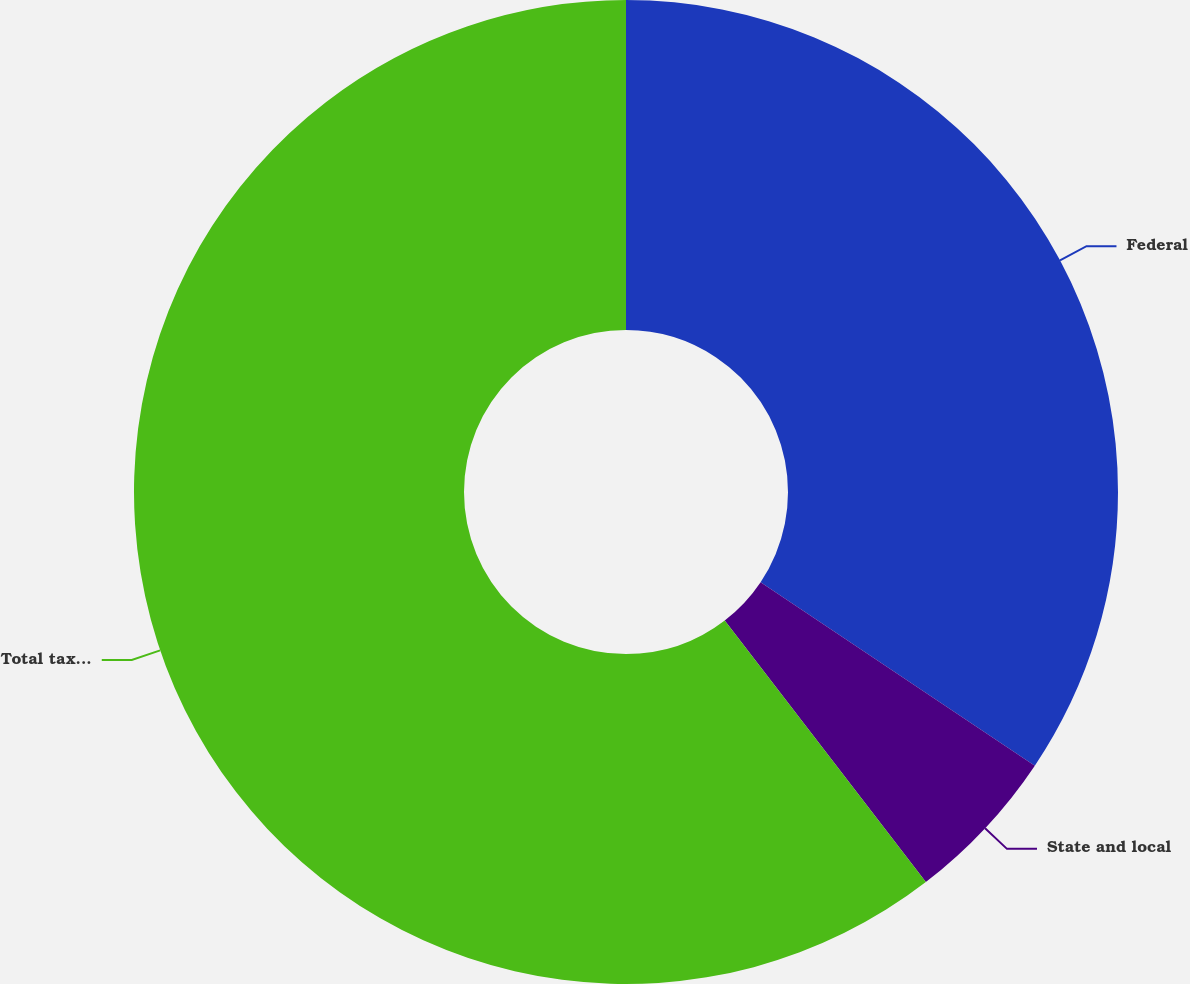Convert chart to OTSL. <chart><loc_0><loc_0><loc_500><loc_500><pie_chart><fcel>Federal<fcel>State and local<fcel>Total tax expense<nl><fcel>34.39%<fcel>5.18%<fcel>60.43%<nl></chart> 